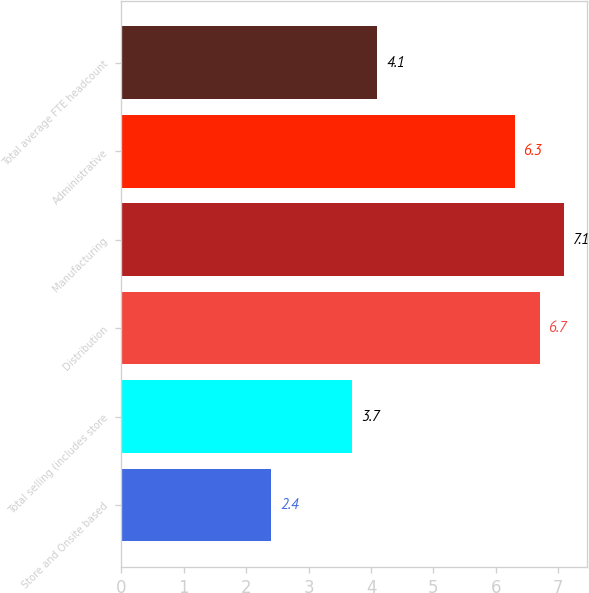<chart> <loc_0><loc_0><loc_500><loc_500><bar_chart><fcel>Store and Onsite based<fcel>Total selling (includes store<fcel>Distribution<fcel>Manufacturing<fcel>Administrative<fcel>Total average FTE headcount<nl><fcel>2.4<fcel>3.7<fcel>6.7<fcel>7.1<fcel>6.3<fcel>4.1<nl></chart> 